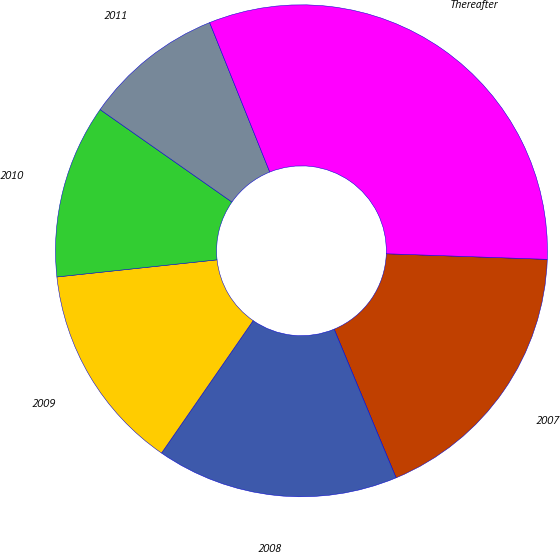<chart> <loc_0><loc_0><loc_500><loc_500><pie_chart><fcel>2007<fcel>2008<fcel>2009<fcel>2010<fcel>2011<fcel>Thereafter<nl><fcel>18.16%<fcel>15.92%<fcel>13.67%<fcel>11.43%<fcel>9.18%<fcel>31.64%<nl></chart> 